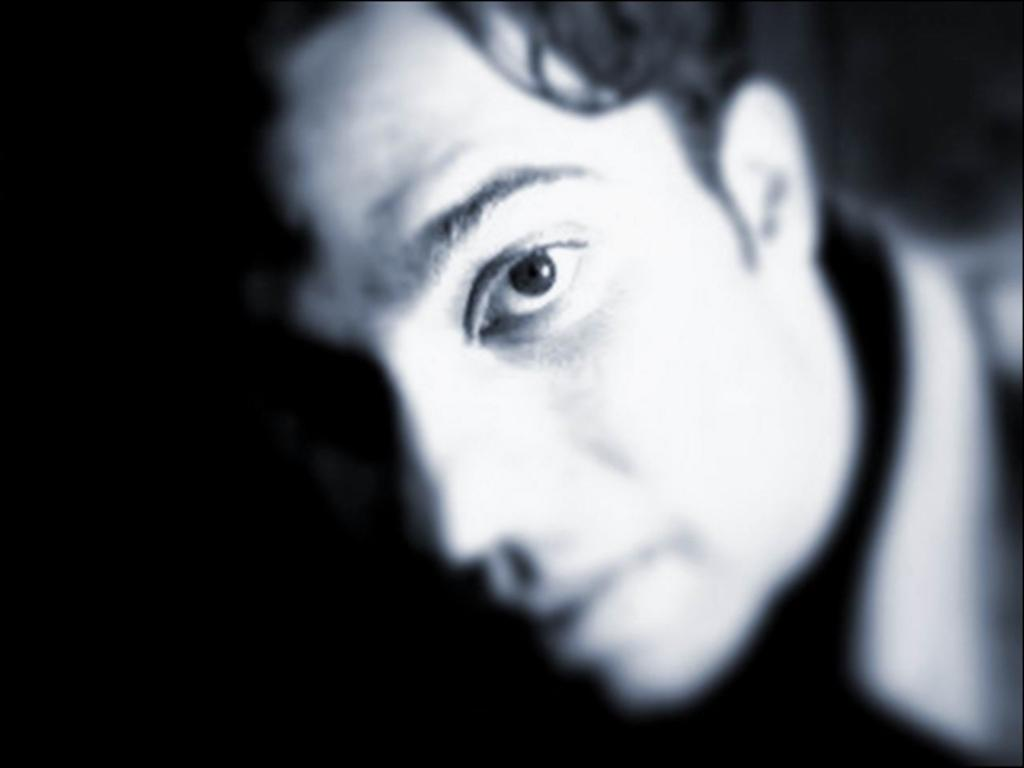Who or what is the main subject of the image? There is a person in the image. Can you describe the background of the image? The background of the image is dark. How much sugar is on the paper in the image? There is no paper or sugar present in the image; it only features a person with a dark background. 